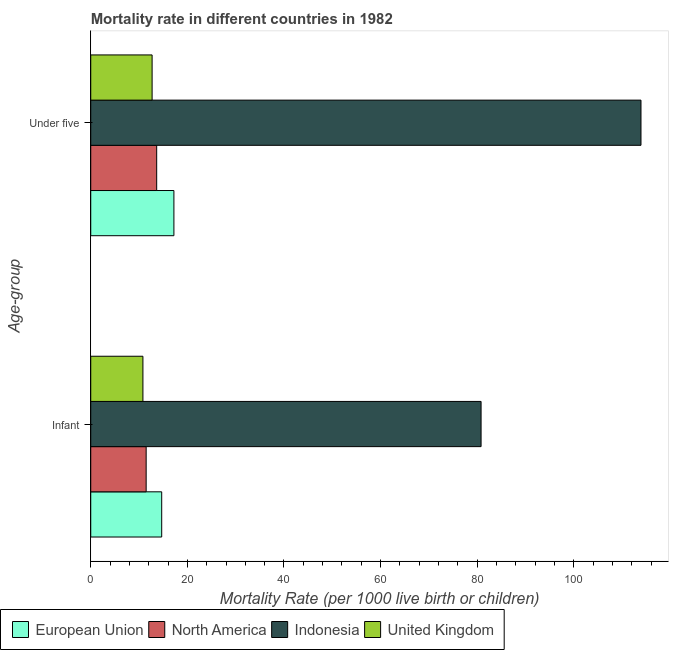How many different coloured bars are there?
Offer a very short reply. 4. Are the number of bars per tick equal to the number of legend labels?
Keep it short and to the point. Yes. How many bars are there on the 2nd tick from the bottom?
Keep it short and to the point. 4. What is the label of the 1st group of bars from the top?
Make the answer very short. Under five. Across all countries, what is the maximum infant mortality rate?
Ensure brevity in your answer.  80.8. In which country was the infant mortality rate maximum?
Your response must be concise. Indonesia. What is the total infant mortality rate in the graph?
Offer a very short reply. 117.76. What is the difference between the infant mortality rate in North America and that in Indonesia?
Offer a terse response. -69.33. What is the difference between the infant mortality rate in European Union and the under-5 mortality rate in United Kingdom?
Ensure brevity in your answer.  1.99. What is the average under-5 mortality rate per country?
Offer a very short reply. 39.37. What is the difference between the infant mortality rate and under-5 mortality rate in Indonesia?
Your answer should be compact. -33.1. What is the ratio of the under-5 mortality rate in North America to that in European Union?
Offer a very short reply. 0.79. What does the 3rd bar from the top in Infant represents?
Your response must be concise. North America. What does the 4th bar from the bottom in Under five represents?
Provide a succinct answer. United Kingdom. How many bars are there?
Offer a very short reply. 8. Are all the bars in the graph horizontal?
Provide a short and direct response. Yes. What is the title of the graph?
Make the answer very short. Mortality rate in different countries in 1982. What is the label or title of the X-axis?
Make the answer very short. Mortality Rate (per 1000 live birth or children). What is the label or title of the Y-axis?
Provide a succinct answer. Age-group. What is the Mortality Rate (per 1000 live birth or children) in European Union in Infant?
Ensure brevity in your answer.  14.69. What is the Mortality Rate (per 1000 live birth or children) of North America in Infant?
Provide a succinct answer. 11.47. What is the Mortality Rate (per 1000 live birth or children) of Indonesia in Infant?
Provide a succinct answer. 80.8. What is the Mortality Rate (per 1000 live birth or children) of European Union in Under five?
Make the answer very short. 17.21. What is the Mortality Rate (per 1000 live birth or children) in North America in Under five?
Your answer should be compact. 13.65. What is the Mortality Rate (per 1000 live birth or children) of Indonesia in Under five?
Provide a short and direct response. 113.9. What is the Mortality Rate (per 1000 live birth or children) of United Kingdom in Under five?
Provide a succinct answer. 12.7. Across all Age-group, what is the maximum Mortality Rate (per 1000 live birth or children) of European Union?
Your answer should be very brief. 17.21. Across all Age-group, what is the maximum Mortality Rate (per 1000 live birth or children) of North America?
Keep it short and to the point. 13.65. Across all Age-group, what is the maximum Mortality Rate (per 1000 live birth or children) in Indonesia?
Provide a short and direct response. 113.9. Across all Age-group, what is the maximum Mortality Rate (per 1000 live birth or children) in United Kingdom?
Provide a succinct answer. 12.7. Across all Age-group, what is the minimum Mortality Rate (per 1000 live birth or children) in European Union?
Give a very brief answer. 14.69. Across all Age-group, what is the minimum Mortality Rate (per 1000 live birth or children) of North America?
Make the answer very short. 11.47. Across all Age-group, what is the minimum Mortality Rate (per 1000 live birth or children) in Indonesia?
Your response must be concise. 80.8. Across all Age-group, what is the minimum Mortality Rate (per 1000 live birth or children) in United Kingdom?
Offer a terse response. 10.8. What is the total Mortality Rate (per 1000 live birth or children) of European Union in the graph?
Keep it short and to the point. 31.9. What is the total Mortality Rate (per 1000 live birth or children) in North America in the graph?
Offer a terse response. 25.12. What is the total Mortality Rate (per 1000 live birth or children) of Indonesia in the graph?
Your answer should be compact. 194.7. What is the difference between the Mortality Rate (per 1000 live birth or children) in European Union in Infant and that in Under five?
Provide a succinct answer. -2.53. What is the difference between the Mortality Rate (per 1000 live birth or children) of North America in Infant and that in Under five?
Make the answer very short. -2.18. What is the difference between the Mortality Rate (per 1000 live birth or children) of Indonesia in Infant and that in Under five?
Give a very brief answer. -33.1. What is the difference between the Mortality Rate (per 1000 live birth or children) in European Union in Infant and the Mortality Rate (per 1000 live birth or children) in North America in Under five?
Your response must be concise. 1.04. What is the difference between the Mortality Rate (per 1000 live birth or children) in European Union in Infant and the Mortality Rate (per 1000 live birth or children) in Indonesia in Under five?
Your answer should be very brief. -99.21. What is the difference between the Mortality Rate (per 1000 live birth or children) in European Union in Infant and the Mortality Rate (per 1000 live birth or children) in United Kingdom in Under five?
Offer a terse response. 1.99. What is the difference between the Mortality Rate (per 1000 live birth or children) in North America in Infant and the Mortality Rate (per 1000 live birth or children) in Indonesia in Under five?
Your response must be concise. -102.43. What is the difference between the Mortality Rate (per 1000 live birth or children) of North America in Infant and the Mortality Rate (per 1000 live birth or children) of United Kingdom in Under five?
Your answer should be very brief. -1.23. What is the difference between the Mortality Rate (per 1000 live birth or children) of Indonesia in Infant and the Mortality Rate (per 1000 live birth or children) of United Kingdom in Under five?
Provide a short and direct response. 68.1. What is the average Mortality Rate (per 1000 live birth or children) of European Union per Age-group?
Offer a very short reply. 15.95. What is the average Mortality Rate (per 1000 live birth or children) of North America per Age-group?
Your answer should be very brief. 12.56. What is the average Mortality Rate (per 1000 live birth or children) in Indonesia per Age-group?
Your answer should be compact. 97.35. What is the average Mortality Rate (per 1000 live birth or children) in United Kingdom per Age-group?
Offer a very short reply. 11.75. What is the difference between the Mortality Rate (per 1000 live birth or children) of European Union and Mortality Rate (per 1000 live birth or children) of North America in Infant?
Give a very brief answer. 3.22. What is the difference between the Mortality Rate (per 1000 live birth or children) of European Union and Mortality Rate (per 1000 live birth or children) of Indonesia in Infant?
Offer a very short reply. -66.11. What is the difference between the Mortality Rate (per 1000 live birth or children) of European Union and Mortality Rate (per 1000 live birth or children) of United Kingdom in Infant?
Keep it short and to the point. 3.89. What is the difference between the Mortality Rate (per 1000 live birth or children) of North America and Mortality Rate (per 1000 live birth or children) of Indonesia in Infant?
Ensure brevity in your answer.  -69.33. What is the difference between the Mortality Rate (per 1000 live birth or children) in North America and Mortality Rate (per 1000 live birth or children) in United Kingdom in Infant?
Provide a succinct answer. 0.67. What is the difference between the Mortality Rate (per 1000 live birth or children) in European Union and Mortality Rate (per 1000 live birth or children) in North America in Under five?
Provide a short and direct response. 3.56. What is the difference between the Mortality Rate (per 1000 live birth or children) in European Union and Mortality Rate (per 1000 live birth or children) in Indonesia in Under five?
Offer a terse response. -96.69. What is the difference between the Mortality Rate (per 1000 live birth or children) in European Union and Mortality Rate (per 1000 live birth or children) in United Kingdom in Under five?
Your response must be concise. 4.51. What is the difference between the Mortality Rate (per 1000 live birth or children) in North America and Mortality Rate (per 1000 live birth or children) in Indonesia in Under five?
Make the answer very short. -100.25. What is the difference between the Mortality Rate (per 1000 live birth or children) of North America and Mortality Rate (per 1000 live birth or children) of United Kingdom in Under five?
Ensure brevity in your answer.  0.95. What is the difference between the Mortality Rate (per 1000 live birth or children) of Indonesia and Mortality Rate (per 1000 live birth or children) of United Kingdom in Under five?
Provide a succinct answer. 101.2. What is the ratio of the Mortality Rate (per 1000 live birth or children) of European Union in Infant to that in Under five?
Give a very brief answer. 0.85. What is the ratio of the Mortality Rate (per 1000 live birth or children) in North America in Infant to that in Under five?
Your answer should be compact. 0.84. What is the ratio of the Mortality Rate (per 1000 live birth or children) in Indonesia in Infant to that in Under five?
Ensure brevity in your answer.  0.71. What is the ratio of the Mortality Rate (per 1000 live birth or children) in United Kingdom in Infant to that in Under five?
Your response must be concise. 0.85. What is the difference between the highest and the second highest Mortality Rate (per 1000 live birth or children) of European Union?
Give a very brief answer. 2.53. What is the difference between the highest and the second highest Mortality Rate (per 1000 live birth or children) in North America?
Provide a short and direct response. 2.18. What is the difference between the highest and the second highest Mortality Rate (per 1000 live birth or children) of Indonesia?
Your answer should be compact. 33.1. What is the difference between the highest and the second highest Mortality Rate (per 1000 live birth or children) in United Kingdom?
Keep it short and to the point. 1.9. What is the difference between the highest and the lowest Mortality Rate (per 1000 live birth or children) of European Union?
Offer a very short reply. 2.53. What is the difference between the highest and the lowest Mortality Rate (per 1000 live birth or children) in North America?
Make the answer very short. 2.18. What is the difference between the highest and the lowest Mortality Rate (per 1000 live birth or children) in Indonesia?
Your answer should be very brief. 33.1. What is the difference between the highest and the lowest Mortality Rate (per 1000 live birth or children) in United Kingdom?
Offer a terse response. 1.9. 